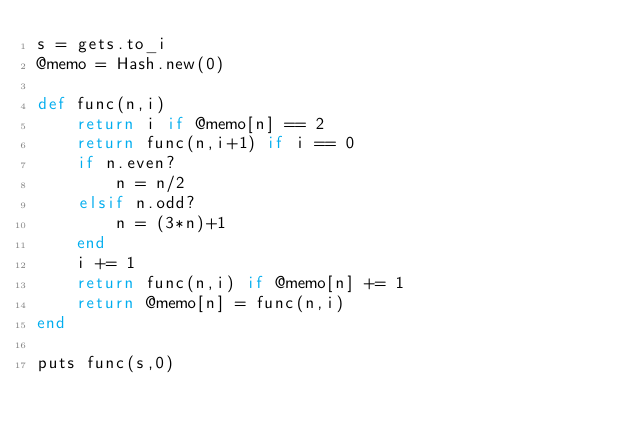<code> <loc_0><loc_0><loc_500><loc_500><_Ruby_>s = gets.to_i
@memo = Hash.new(0)

def func(n,i)
    return i if @memo[n] == 2
    return func(n,i+1) if i == 0
    if n.even?
        n = n/2
    elsif n.odd?
        n = (3*n)+1
    end
    i += 1
    return func(n,i) if @memo[n] += 1
    return @memo[n] = func(n,i)
end

puts func(s,0)</code> 